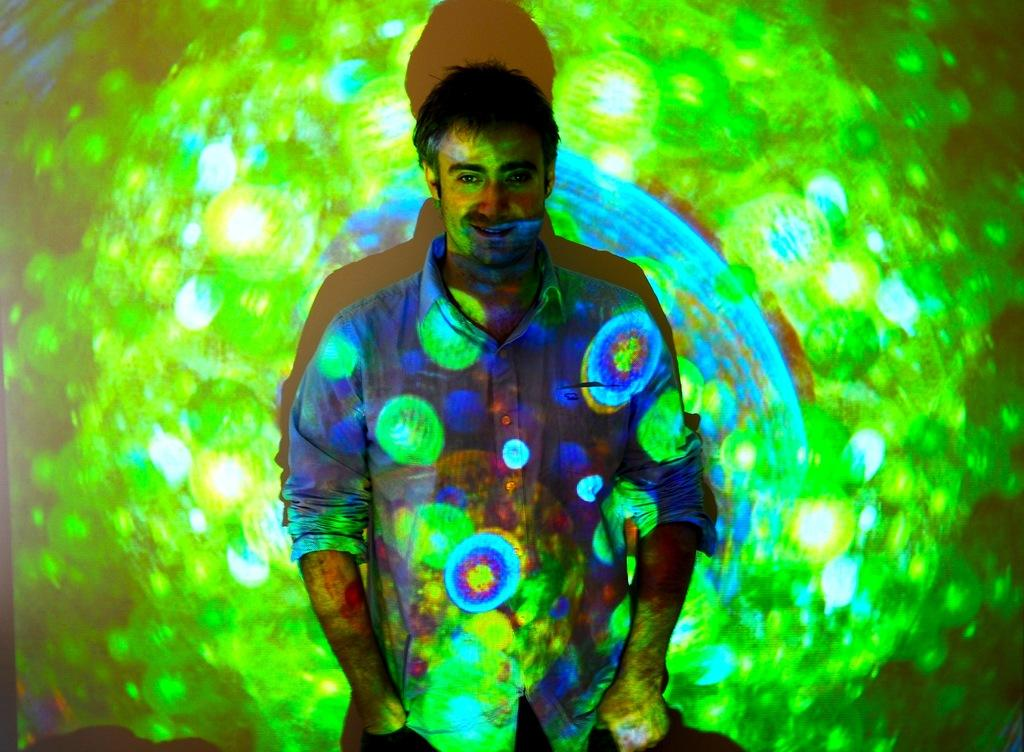What is the main subject of the image? There is a person standing in the image. What is the person wearing? The person is wearing a blue dress. What type of lighting can be seen in the image? There is colorful lighting visible in the image. How many patches can be seen on the banana in the image? There is no banana present in the image, and therefore no patches can be seen. 